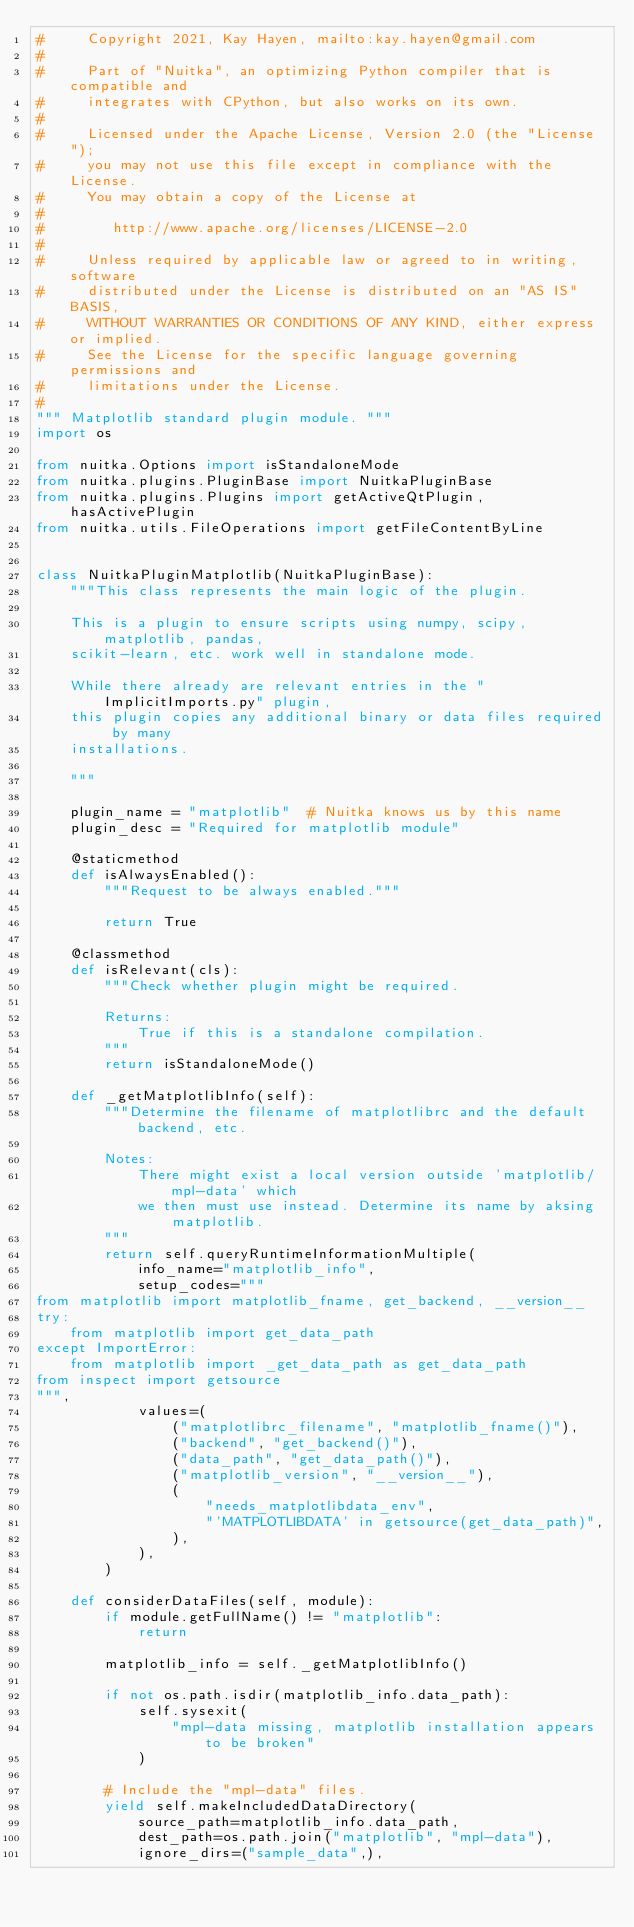Convert code to text. <code><loc_0><loc_0><loc_500><loc_500><_Python_>#     Copyright 2021, Kay Hayen, mailto:kay.hayen@gmail.com
#
#     Part of "Nuitka", an optimizing Python compiler that is compatible and
#     integrates with CPython, but also works on its own.
#
#     Licensed under the Apache License, Version 2.0 (the "License");
#     you may not use this file except in compliance with the License.
#     You may obtain a copy of the License at
#
#        http://www.apache.org/licenses/LICENSE-2.0
#
#     Unless required by applicable law or agreed to in writing, software
#     distributed under the License is distributed on an "AS IS" BASIS,
#     WITHOUT WARRANTIES OR CONDITIONS OF ANY KIND, either express or implied.
#     See the License for the specific language governing permissions and
#     limitations under the License.
#
""" Matplotlib standard plugin module. """
import os

from nuitka.Options import isStandaloneMode
from nuitka.plugins.PluginBase import NuitkaPluginBase
from nuitka.plugins.Plugins import getActiveQtPlugin, hasActivePlugin
from nuitka.utils.FileOperations import getFileContentByLine


class NuitkaPluginMatplotlib(NuitkaPluginBase):
    """This class represents the main logic of the plugin.

    This is a plugin to ensure scripts using numpy, scipy, matplotlib, pandas,
    scikit-learn, etc. work well in standalone mode.

    While there already are relevant entries in the "ImplicitImports.py" plugin,
    this plugin copies any additional binary or data files required by many
    installations.

    """

    plugin_name = "matplotlib"  # Nuitka knows us by this name
    plugin_desc = "Required for matplotlib module"

    @staticmethod
    def isAlwaysEnabled():
        """Request to be always enabled."""

        return True

    @classmethod
    def isRelevant(cls):
        """Check whether plugin might be required.

        Returns:
            True if this is a standalone compilation.
        """
        return isStandaloneMode()

    def _getMatplotlibInfo(self):
        """Determine the filename of matplotlibrc and the default backend, etc.

        Notes:
            There might exist a local version outside 'matplotlib/mpl-data' which
            we then must use instead. Determine its name by aksing matplotlib.
        """
        return self.queryRuntimeInformationMultiple(
            info_name="matplotlib_info",
            setup_codes="""
from matplotlib import matplotlib_fname, get_backend, __version__
try:
    from matplotlib import get_data_path
except ImportError:
    from matplotlib import _get_data_path as get_data_path
from inspect import getsource
""",
            values=(
                ("matplotlibrc_filename", "matplotlib_fname()"),
                ("backend", "get_backend()"),
                ("data_path", "get_data_path()"),
                ("matplotlib_version", "__version__"),
                (
                    "needs_matplotlibdata_env",
                    "'MATPLOTLIBDATA' in getsource(get_data_path)",
                ),
            ),
        )

    def considerDataFiles(self, module):
        if module.getFullName() != "matplotlib":
            return

        matplotlib_info = self._getMatplotlibInfo()

        if not os.path.isdir(matplotlib_info.data_path):
            self.sysexit(
                "mpl-data missing, matplotlib installation appears to be broken"
            )

        # Include the "mpl-data" files.
        yield self.makeIncludedDataDirectory(
            source_path=matplotlib_info.data_path,
            dest_path=os.path.join("matplotlib", "mpl-data"),
            ignore_dirs=("sample_data",),</code> 